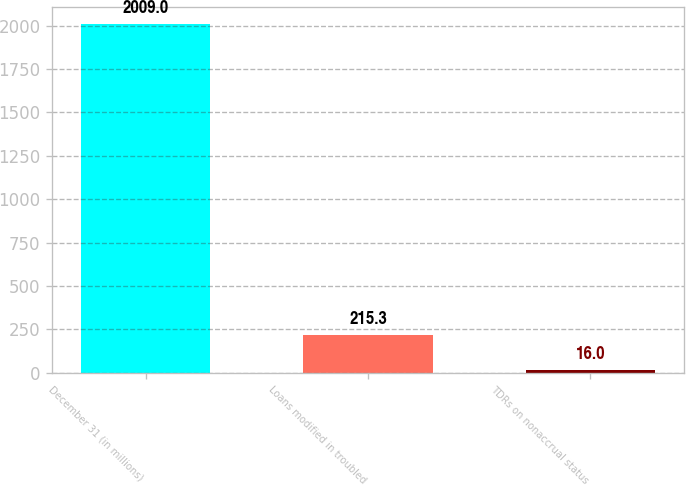<chart> <loc_0><loc_0><loc_500><loc_500><bar_chart><fcel>December 31 (in millions)<fcel>Loans modified in troubled<fcel>TDRs on nonaccrual status<nl><fcel>2009<fcel>215.3<fcel>16<nl></chart> 